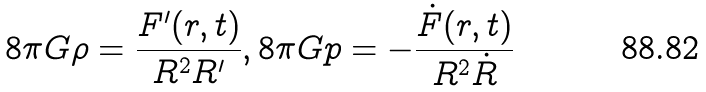<formula> <loc_0><loc_0><loc_500><loc_500>8 \pi G \rho = \frac { F ^ { \prime } ( r , t ) } { R ^ { 2 } R ^ { \prime } } , 8 \pi G p = - \frac { \dot { F } ( r , t ) } { R ^ { 2 } \dot { R } }</formula> 